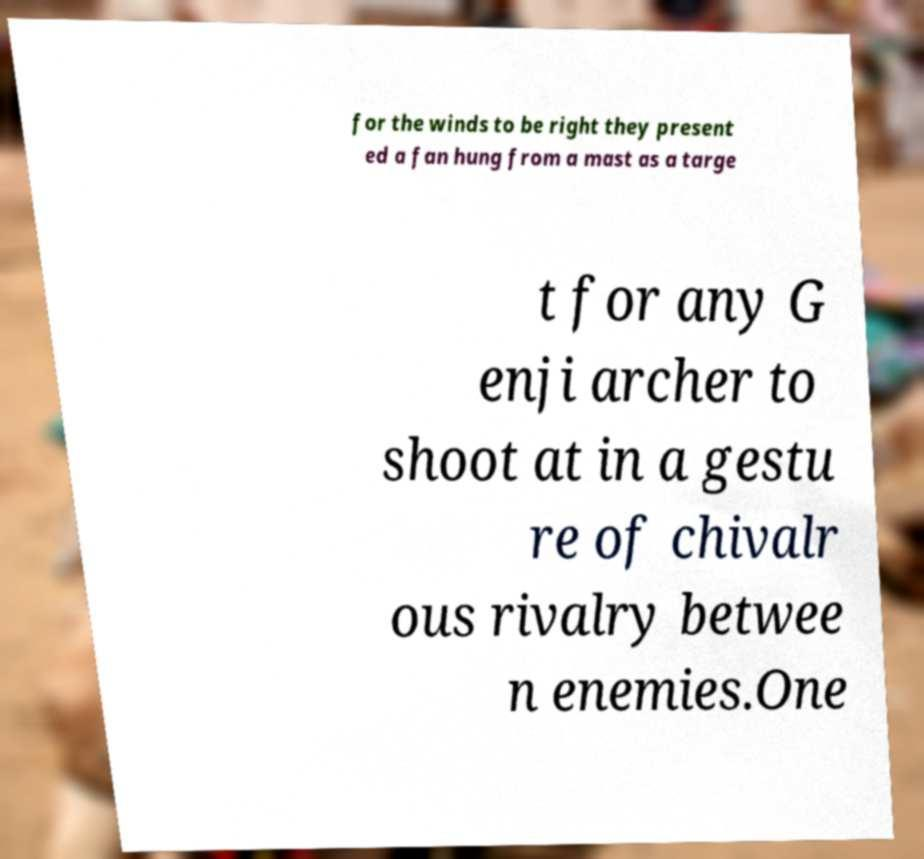Could you extract and type out the text from this image? for the winds to be right they present ed a fan hung from a mast as a targe t for any G enji archer to shoot at in a gestu re of chivalr ous rivalry betwee n enemies.One 